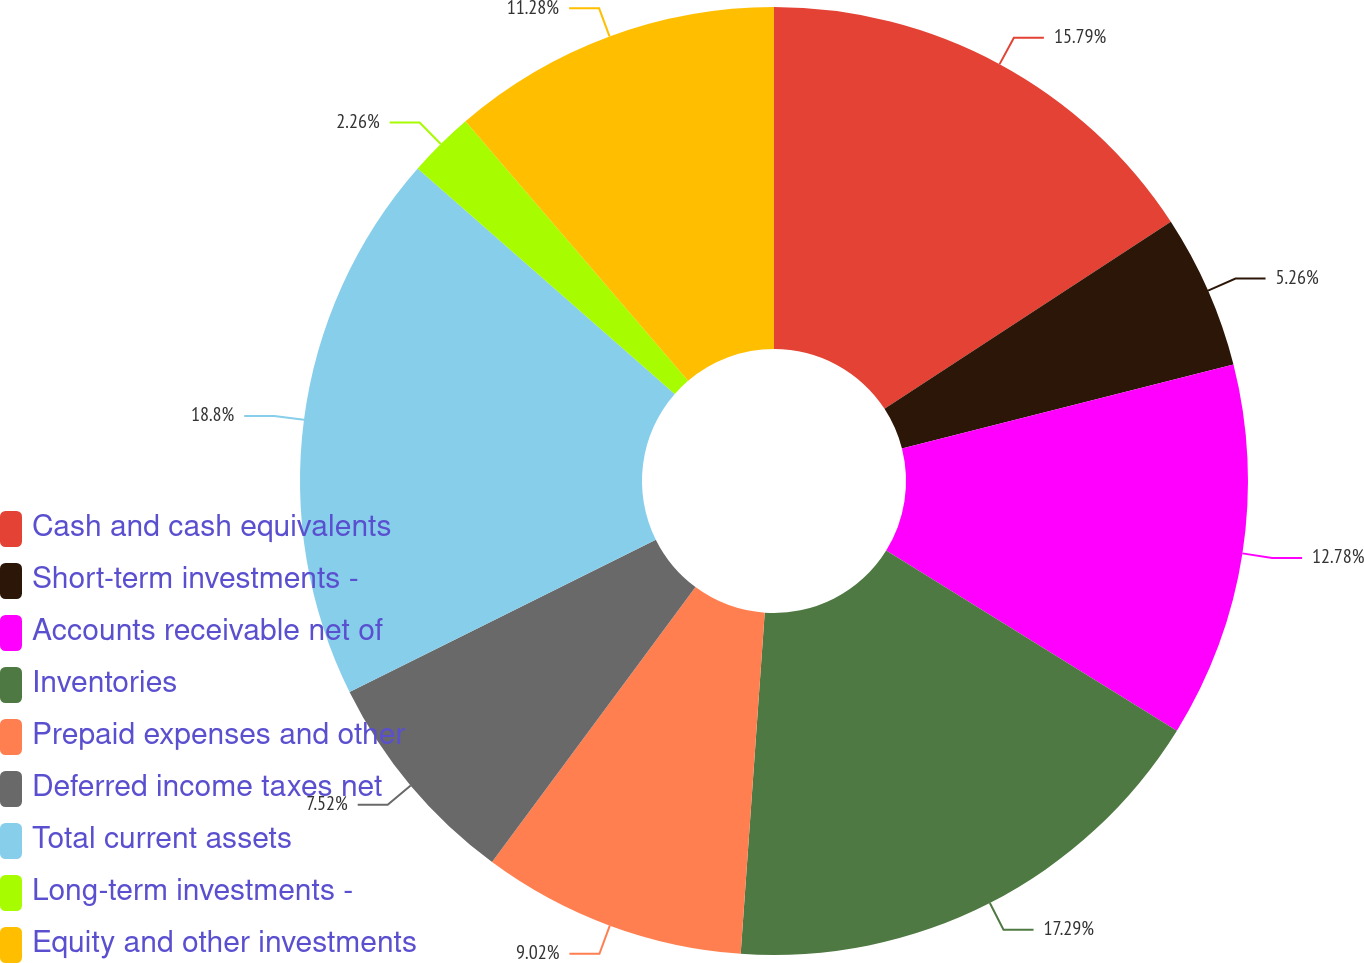<chart> <loc_0><loc_0><loc_500><loc_500><pie_chart><fcel>Cash and cash equivalents<fcel>Short-term investments -<fcel>Accounts receivable net of<fcel>Inventories<fcel>Prepaid expenses and other<fcel>Deferred income taxes net<fcel>Total current assets<fcel>Long-term investments -<fcel>Equity and other investments<nl><fcel>15.79%<fcel>5.26%<fcel>12.78%<fcel>17.29%<fcel>9.02%<fcel>7.52%<fcel>18.8%<fcel>2.26%<fcel>11.28%<nl></chart> 